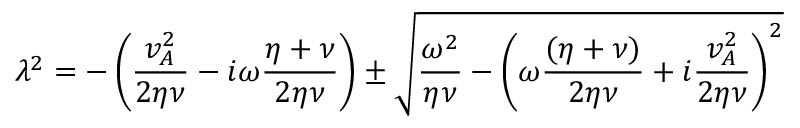<formula> <loc_0><loc_0><loc_500><loc_500>\lambda ^ { 2 } = - \left ( \frac { v _ { A } ^ { 2 } } { 2 \eta \nu } - i \omega \frac { \eta + \nu } { 2 \eta \nu } \right ) \pm \sqrt { \frac { \omega ^ { 2 } } { \eta \nu } - \left ( \omega \frac { ( \eta + \nu ) } { 2 \eta \nu } + i \frac { v _ { A } ^ { 2 } } { 2 \eta \nu } \right ) ^ { 2 } }</formula> 